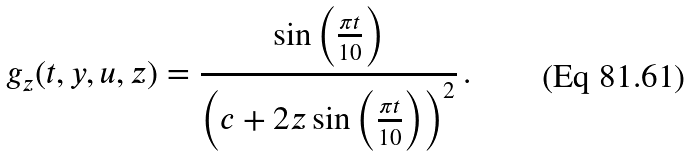Convert formula to latex. <formula><loc_0><loc_0><loc_500><loc_500>g _ { z } ( t , y , u , z ) = \frac { \sin \left ( \frac { \pi t } { 1 0 } \right ) } { \left ( c + 2 z \sin \left ( \frac { \pi t } { 1 0 } \right ) \right ) ^ { 2 } } \, .</formula> 